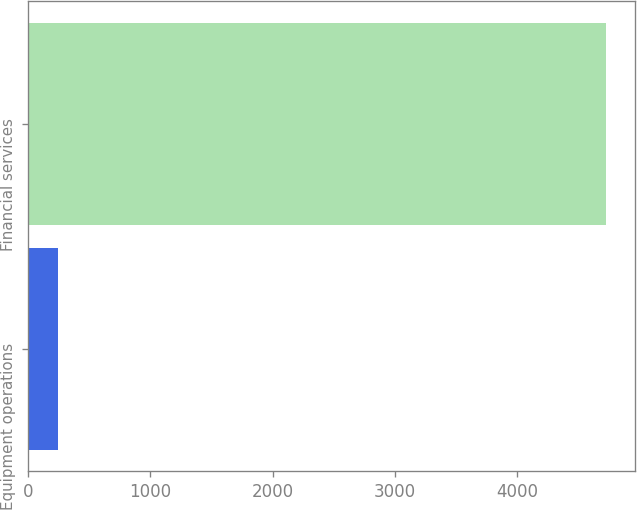<chart> <loc_0><loc_0><loc_500><loc_500><bar_chart><fcel>Equipment operations<fcel>Financial services<nl><fcel>243<fcel>4730<nl></chart> 